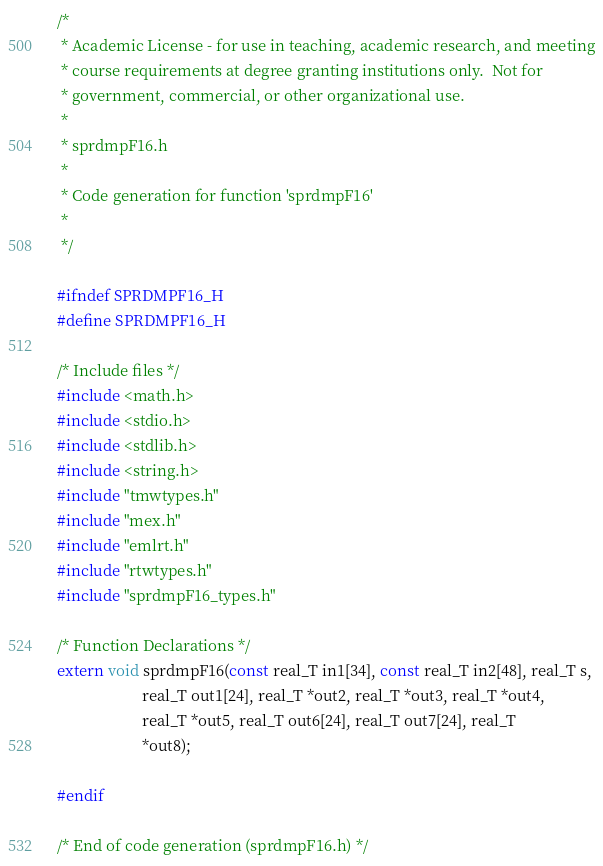<code> <loc_0><loc_0><loc_500><loc_500><_C_>/*
 * Academic License - for use in teaching, academic research, and meeting
 * course requirements at degree granting institutions only.  Not for
 * government, commercial, or other organizational use.
 *
 * sprdmpF16.h
 *
 * Code generation for function 'sprdmpF16'
 *
 */

#ifndef SPRDMPF16_H
#define SPRDMPF16_H

/* Include files */
#include <math.h>
#include <stdio.h>
#include <stdlib.h>
#include <string.h>
#include "tmwtypes.h"
#include "mex.h"
#include "emlrt.h"
#include "rtwtypes.h"
#include "sprdmpF16_types.h"

/* Function Declarations */
extern void sprdmpF16(const real_T in1[34], const real_T in2[48], real_T s,
                      real_T out1[24], real_T *out2, real_T *out3, real_T *out4,
                      real_T *out5, real_T out6[24], real_T out7[24], real_T
                      *out8);

#endif

/* End of code generation (sprdmpF16.h) */
</code> 